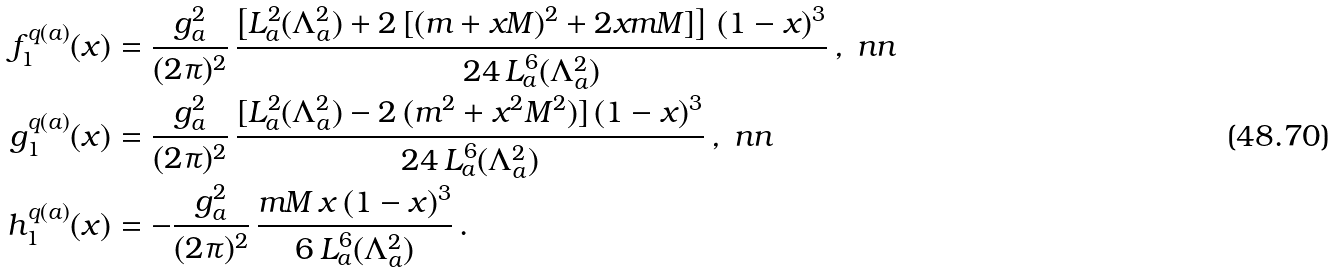Convert formula to latex. <formula><loc_0><loc_0><loc_500><loc_500>f _ { 1 } ^ { q ( a ) } ( x ) & = \frac { g _ { a } ^ { 2 } } { ( 2 \pi ) ^ { 2 } } \, \frac { \left [ L _ { a } ^ { 2 } ( \Lambda _ { a } ^ { 2 } ) + 2 \, [ ( m + x M ) ^ { 2 } + 2 x m M ] \right ] \, ( 1 - x ) ^ { 3 } } { 2 4 \, L _ { a } ^ { 6 } ( \Lambda _ { a } ^ { 2 } ) } \, , \ n n \\ g _ { 1 } ^ { q ( a ) } ( x ) & = \frac { g _ { a } ^ { 2 } } { ( 2 \pi ) ^ { 2 } } \, \frac { [ L _ { a } ^ { 2 } ( \Lambda _ { a } ^ { 2 } ) - 2 \, ( m ^ { 2 } + x ^ { 2 } M ^ { 2 } ) ] \, ( 1 - x ) ^ { 3 } } { 2 4 \, L _ { a } ^ { 6 } ( \Lambda _ { a } ^ { 2 } ) } \, , \ n n \\ h _ { 1 } ^ { q ( a ) } ( x ) & = - \frac { g _ { a } ^ { 2 } } { ( 2 \pi ) ^ { 2 } } \, \frac { m M \, x \, ( 1 - x ) ^ { 3 } } { 6 \, L _ { a } ^ { 6 } ( \Lambda _ { a } ^ { 2 } ) } \, .</formula> 